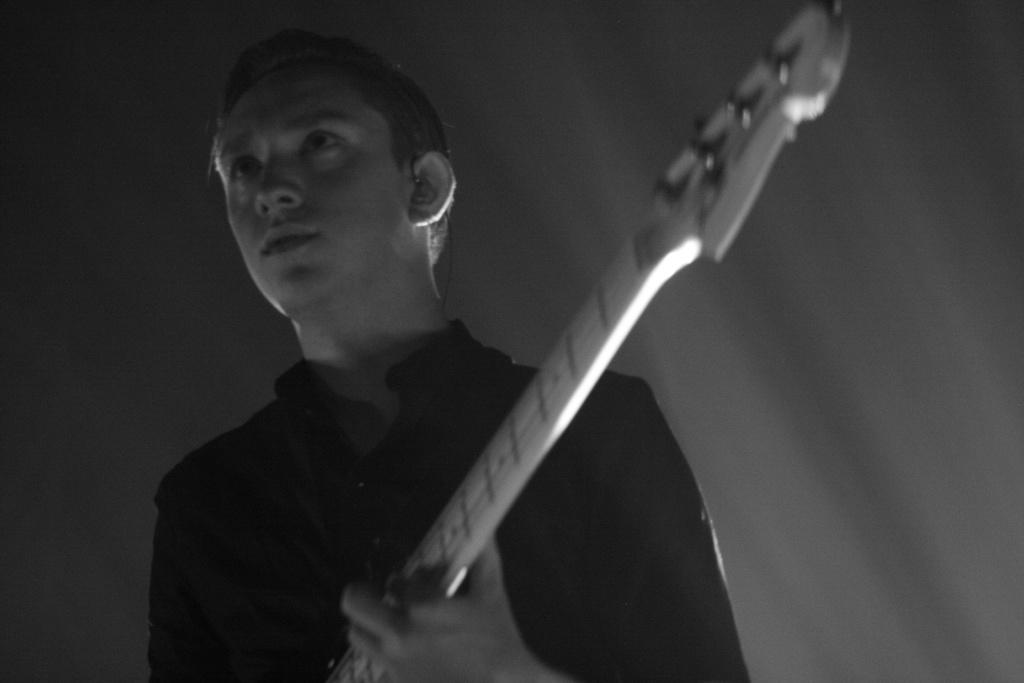What is the man in the image doing? The man is playing a guitar in the image. What is the color scheme of the image? The image is black and white. What type of whip is the man using to play the guitar in the image? There is no whip present in the image; the man is playing the guitar with his hands. What type of wine is the man drinking while playing the guitar in the image? There is no wine present in the image; the man is focused on playing the guitar. 